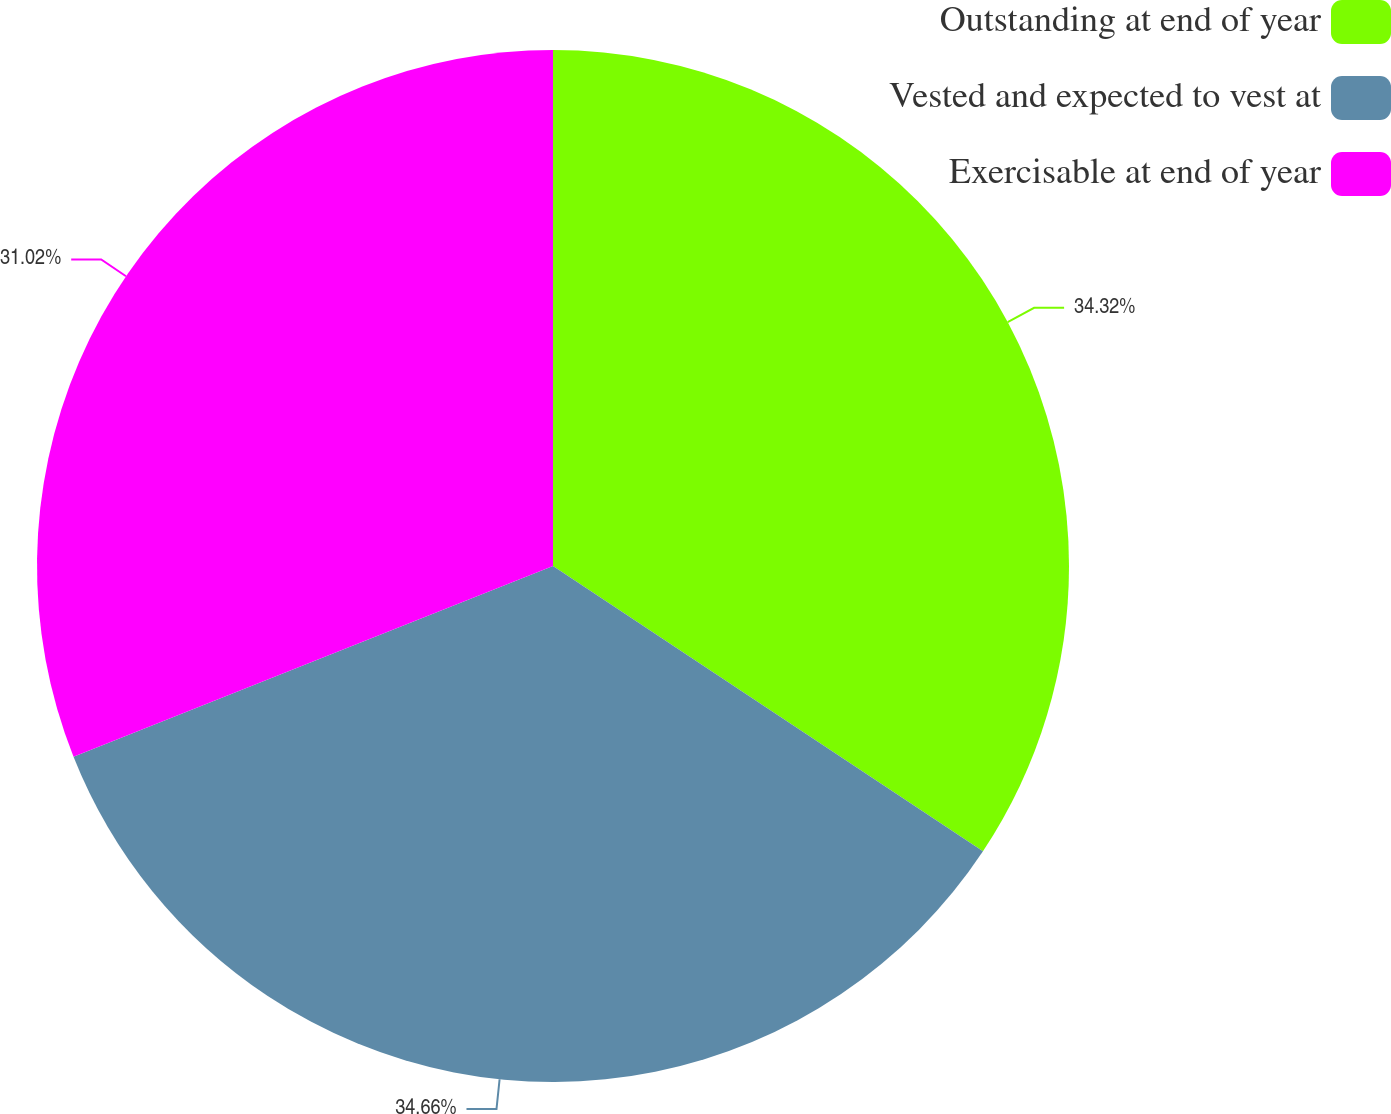Convert chart. <chart><loc_0><loc_0><loc_500><loc_500><pie_chart><fcel>Outstanding at end of year<fcel>Vested and expected to vest at<fcel>Exercisable at end of year<nl><fcel>34.32%<fcel>34.65%<fcel>31.02%<nl></chart> 